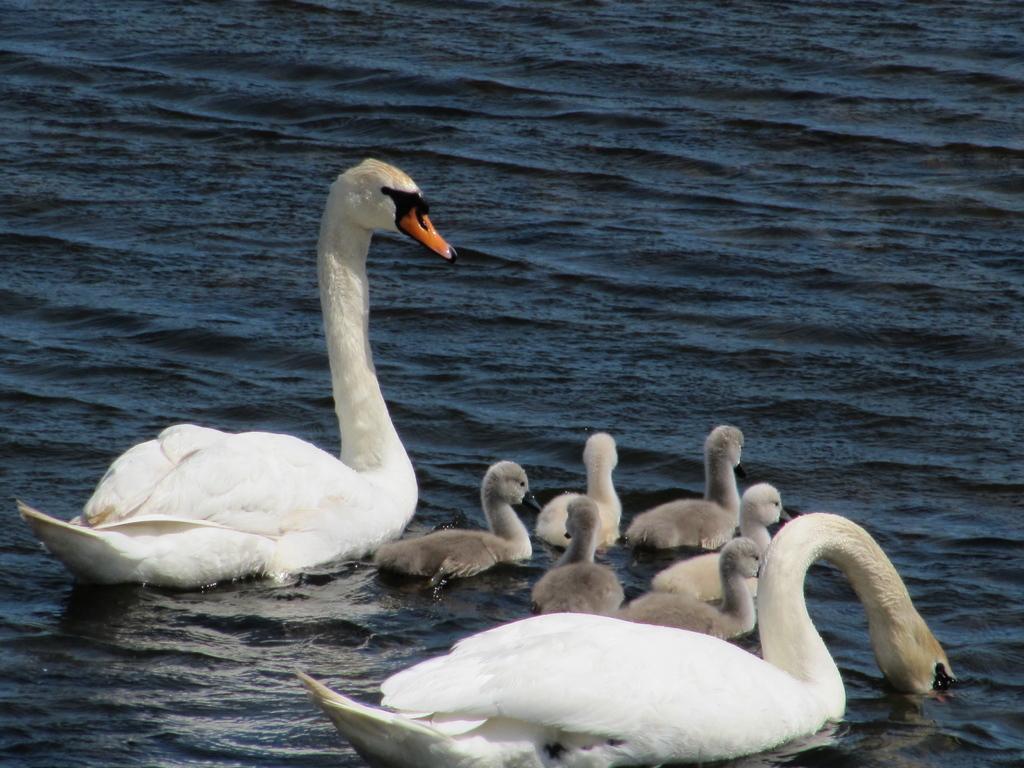Describe this image in one or two sentences. In this picture, we can see birds and a few baby birds on the water. 